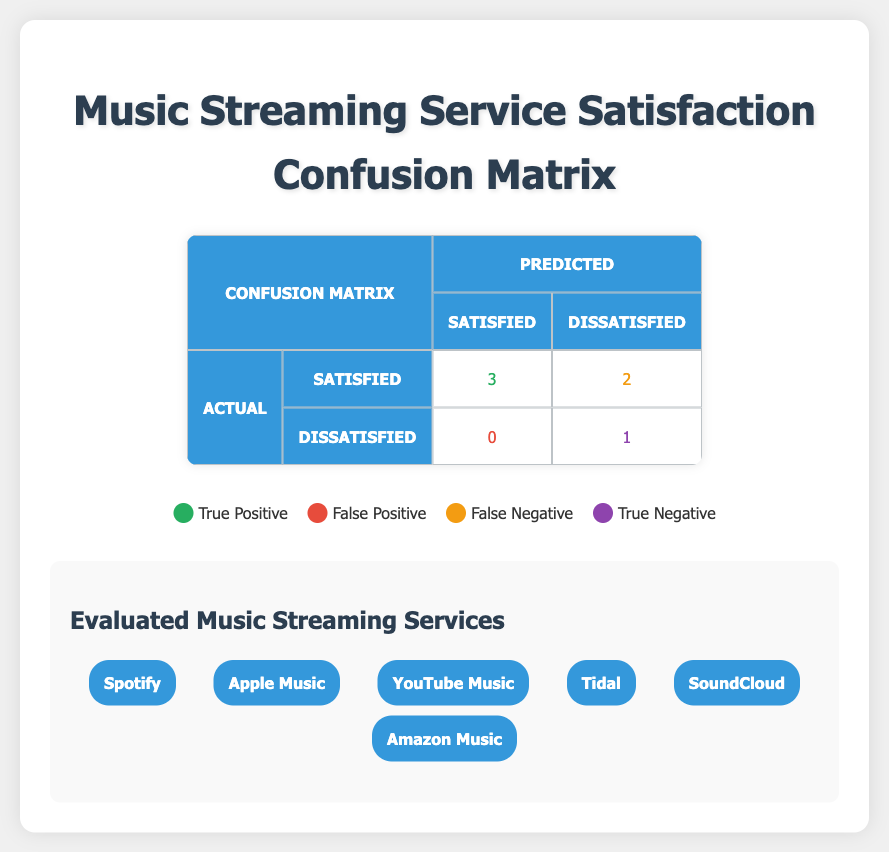What is the total number of True Positives in the confusion matrix? The confusion matrix indicates that the True Positive value is represented by the number 3. This corresponds to the instances where the service was predicted as "Satisfied" and was also "Satisfied" in reality. Therefore, the total number of True Positives is 3.
Answer: 3 How many services were predicted as Satisfied but were actually Dissatisfied? This refers to the False Positive value in the confusion matrix, which shows that 0 services were incorrectly predicted as "Satisfied" when they were actually "Dissatisfied." Thus, the count is 0.
Answer: 0 What is the total number of services that were dissatisfied according to the actual results? The actual results list 2 services categorized as "Dissatisfied," that is, SoundCloud and Amazon Music. Hence, the total number of services that were dissatisfied is 2.
Answer: 2 What is the total number of services that the model predicted to be Dissatisfied? The predicted values show there are 3 services categorized as "Dissatisfied" (SoundCloud, Tidal, and Amazon Music). Hence, the total predicted as Dissatisfied is 3.
Answer: 3 Is it true that all services that were predicted as Satisfied were actually Satisfied? By examining the predicted and actual boxes, every service predicted as "Satisfied" (Spotify, Apple Music, YouTube Music) indeed matches the actual results. Therefore, the statement is true.
Answer: Yes What is the difference between the number of True Negatives and False Negatives? True Negatives (1) and False Negatives (2) can be compared by calculating the difference. The calculation is 1 (True Negative) - 2 (False Negative) = -1. Hence, the difference is -1.
Answer: -1 How many total evaluations were conducted for the music streaming services? For total evaluations, add up all the unique services listed in the provided data points: Spotify, Apple Music, YouTube Music, Tidal, SoundCloud, and Amazon Music, which sums to a total of 6 services evaluated.
Answer: 6 Which service was predicted to be Dissatisfied but was actually Satisfied? From the data points, Tidal was predicted as "Dissatisfied" but was actually "Satisfied." This is identified by looking at the row for Tidal in the provided data.
Answer: Tidal What is the total number of True Positives and True Negatives combined? The total can be calculated by adding the True Positives (3) and True Negatives (1) from the confusion matrix. Therefore, 3 + 1 equals 4.
Answer: 4 